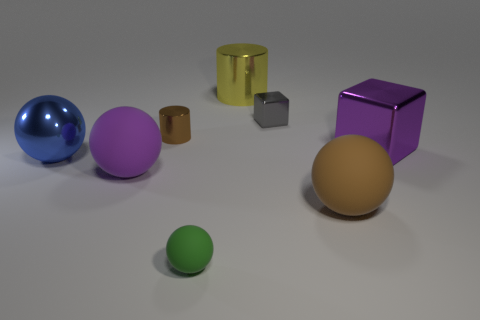Subtract 1 spheres. How many spheres are left? 3 Subtract all yellow spheres. Subtract all purple blocks. How many spheres are left? 4 Add 2 large metallic objects. How many objects exist? 10 Subtract all cylinders. How many objects are left? 6 Subtract 0 cyan spheres. How many objects are left? 8 Subtract all large purple spheres. Subtract all tiny gray metallic blocks. How many objects are left? 6 Add 1 rubber spheres. How many rubber spheres are left? 4 Add 1 small cyan rubber balls. How many small cyan rubber balls exist? 1 